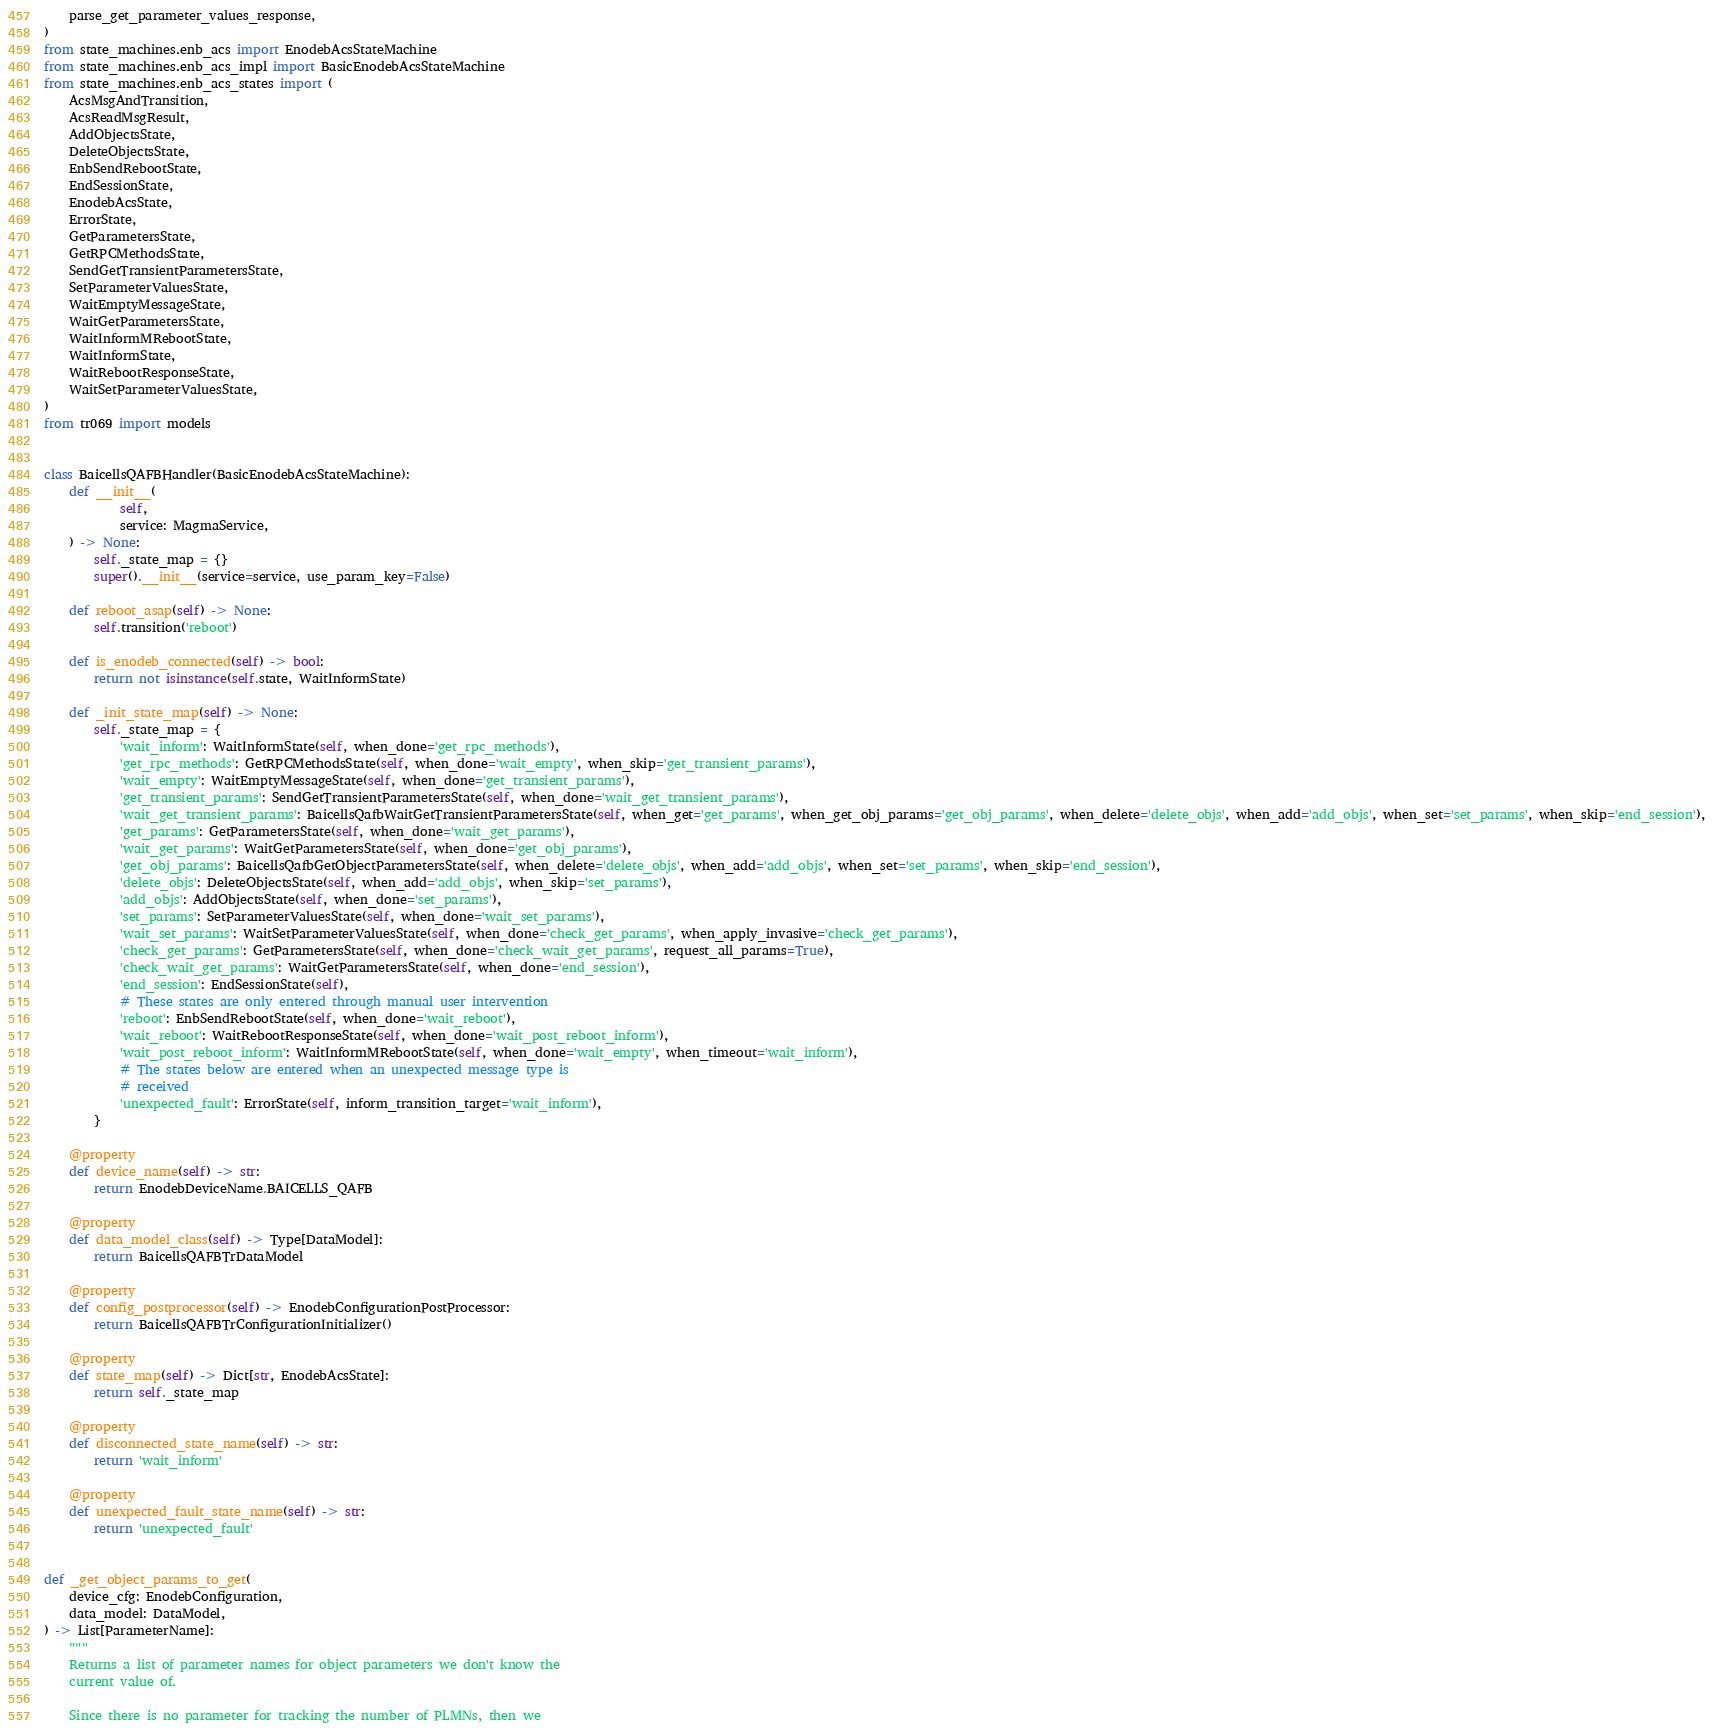Convert code to text. <code><loc_0><loc_0><loc_500><loc_500><_Python_>    parse_get_parameter_values_response,
)
from state_machines.enb_acs import EnodebAcsStateMachine
from state_machines.enb_acs_impl import BasicEnodebAcsStateMachine
from state_machines.enb_acs_states import (
    AcsMsgAndTransition,
    AcsReadMsgResult,
    AddObjectsState,
    DeleteObjectsState,
    EnbSendRebootState,
    EndSessionState,
    EnodebAcsState,
    ErrorState,
    GetParametersState,
    GetRPCMethodsState,
    SendGetTransientParametersState,
    SetParameterValuesState,
    WaitEmptyMessageState,
    WaitGetParametersState,
    WaitInformMRebootState,
    WaitInformState,
    WaitRebootResponseState,
    WaitSetParameterValuesState,
)
from tr069 import models


class BaicellsQAFBHandler(BasicEnodebAcsStateMachine):
    def __init__(
            self,
            service: MagmaService,
    ) -> None:
        self._state_map = {}
        super().__init__(service=service, use_param_key=False)

    def reboot_asap(self) -> None:
        self.transition('reboot')

    def is_enodeb_connected(self) -> bool:
        return not isinstance(self.state, WaitInformState)

    def _init_state_map(self) -> None:
        self._state_map = {
            'wait_inform': WaitInformState(self, when_done='get_rpc_methods'),
            'get_rpc_methods': GetRPCMethodsState(self, when_done='wait_empty', when_skip='get_transient_params'),
            'wait_empty': WaitEmptyMessageState(self, when_done='get_transient_params'),
            'get_transient_params': SendGetTransientParametersState(self, when_done='wait_get_transient_params'),
            'wait_get_transient_params': BaicellsQafbWaitGetTransientParametersState(self, when_get='get_params', when_get_obj_params='get_obj_params', when_delete='delete_objs', when_add='add_objs', when_set='set_params', when_skip='end_session'),
            'get_params': GetParametersState(self, when_done='wait_get_params'),
            'wait_get_params': WaitGetParametersState(self, when_done='get_obj_params'),
            'get_obj_params': BaicellsQafbGetObjectParametersState(self, when_delete='delete_objs', when_add='add_objs', when_set='set_params', when_skip='end_session'),
            'delete_objs': DeleteObjectsState(self, when_add='add_objs', when_skip='set_params'),
            'add_objs': AddObjectsState(self, when_done='set_params'),
            'set_params': SetParameterValuesState(self, when_done='wait_set_params'),
            'wait_set_params': WaitSetParameterValuesState(self, when_done='check_get_params', when_apply_invasive='check_get_params'),
            'check_get_params': GetParametersState(self, when_done='check_wait_get_params', request_all_params=True),
            'check_wait_get_params': WaitGetParametersState(self, when_done='end_session'),
            'end_session': EndSessionState(self),
            # These states are only entered through manual user intervention
            'reboot': EnbSendRebootState(self, when_done='wait_reboot'),
            'wait_reboot': WaitRebootResponseState(self, when_done='wait_post_reboot_inform'),
            'wait_post_reboot_inform': WaitInformMRebootState(self, when_done='wait_empty', when_timeout='wait_inform'),
            # The states below are entered when an unexpected message type is
            # received
            'unexpected_fault': ErrorState(self, inform_transition_target='wait_inform'),
        }

    @property
    def device_name(self) -> str:
        return EnodebDeviceName.BAICELLS_QAFB

    @property
    def data_model_class(self) -> Type[DataModel]:
        return BaicellsQAFBTrDataModel

    @property
    def config_postprocessor(self) -> EnodebConfigurationPostProcessor:
        return BaicellsQAFBTrConfigurationInitializer()

    @property
    def state_map(self) -> Dict[str, EnodebAcsState]:
        return self._state_map

    @property
    def disconnected_state_name(self) -> str:
        return 'wait_inform'

    @property
    def unexpected_fault_state_name(self) -> str:
        return 'unexpected_fault'


def _get_object_params_to_get(
    device_cfg: EnodebConfiguration,
    data_model: DataModel,
) -> List[ParameterName]:
    """
    Returns a list of parameter names for object parameters we don't know the
    current value of.

    Since there is no parameter for tracking the number of PLMNs, then we</code> 